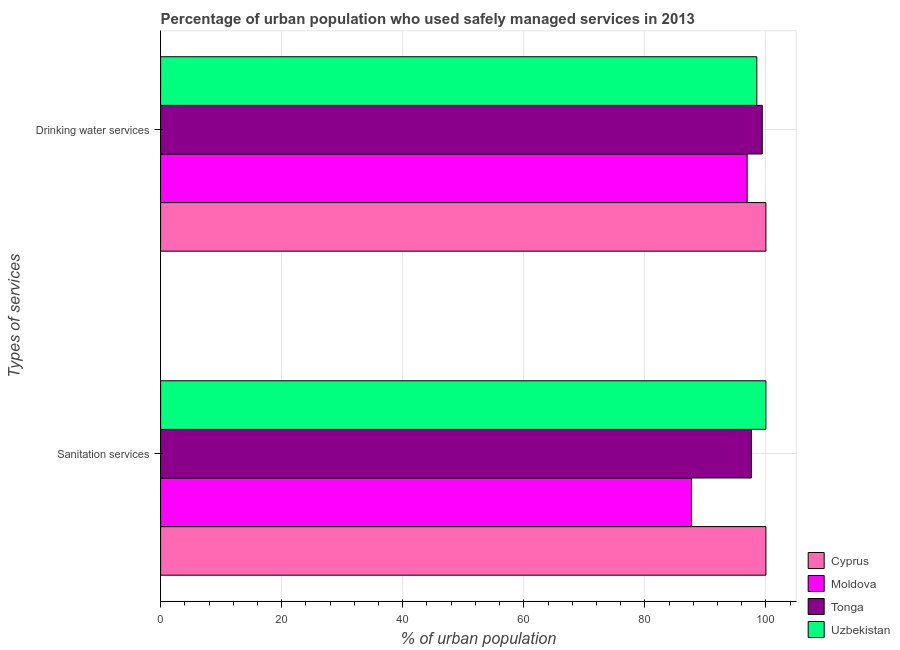How many different coloured bars are there?
Give a very brief answer. 4. How many groups of bars are there?
Keep it short and to the point. 2. How many bars are there on the 2nd tick from the top?
Provide a succinct answer. 4. How many bars are there on the 2nd tick from the bottom?
Keep it short and to the point. 4. What is the label of the 2nd group of bars from the top?
Your answer should be very brief. Sanitation services. What is the percentage of urban population who used drinking water services in Tonga?
Offer a very short reply. 99.4. Across all countries, what is the minimum percentage of urban population who used drinking water services?
Keep it short and to the point. 96.9. In which country was the percentage of urban population who used drinking water services maximum?
Make the answer very short. Cyprus. In which country was the percentage of urban population who used sanitation services minimum?
Ensure brevity in your answer.  Moldova. What is the total percentage of urban population who used sanitation services in the graph?
Your answer should be compact. 385.3. What is the difference between the percentage of urban population who used sanitation services in Cyprus and that in Uzbekistan?
Ensure brevity in your answer.  0. What is the difference between the percentage of urban population who used sanitation services in Tonga and the percentage of urban population who used drinking water services in Moldova?
Offer a very short reply. 0.7. What is the average percentage of urban population who used drinking water services per country?
Provide a succinct answer. 98.7. What is the difference between the percentage of urban population who used drinking water services and percentage of urban population who used sanitation services in Tonga?
Keep it short and to the point. 1.8. In how many countries, is the percentage of urban population who used sanitation services greater than 84 %?
Give a very brief answer. 4. What is the ratio of the percentage of urban population who used drinking water services in Uzbekistan to that in Tonga?
Offer a very short reply. 0.99. What does the 1st bar from the top in Sanitation services represents?
Keep it short and to the point. Uzbekistan. What does the 3rd bar from the bottom in Drinking water services represents?
Keep it short and to the point. Tonga. How many bars are there?
Provide a short and direct response. 8. What is the difference between two consecutive major ticks on the X-axis?
Provide a short and direct response. 20. Are the values on the major ticks of X-axis written in scientific E-notation?
Offer a terse response. No. Does the graph contain any zero values?
Give a very brief answer. No. How many legend labels are there?
Offer a terse response. 4. What is the title of the graph?
Your answer should be compact. Percentage of urban population who used safely managed services in 2013. What is the label or title of the X-axis?
Make the answer very short. % of urban population. What is the label or title of the Y-axis?
Your response must be concise. Types of services. What is the % of urban population in Moldova in Sanitation services?
Provide a short and direct response. 87.7. What is the % of urban population of Tonga in Sanitation services?
Keep it short and to the point. 97.6. What is the % of urban population of Uzbekistan in Sanitation services?
Keep it short and to the point. 100. What is the % of urban population of Cyprus in Drinking water services?
Your answer should be very brief. 100. What is the % of urban population of Moldova in Drinking water services?
Make the answer very short. 96.9. What is the % of urban population in Tonga in Drinking water services?
Keep it short and to the point. 99.4. What is the % of urban population in Uzbekistan in Drinking water services?
Your answer should be very brief. 98.5. Across all Types of services, what is the maximum % of urban population in Moldova?
Keep it short and to the point. 96.9. Across all Types of services, what is the maximum % of urban population of Tonga?
Offer a terse response. 99.4. Across all Types of services, what is the minimum % of urban population of Cyprus?
Provide a short and direct response. 100. Across all Types of services, what is the minimum % of urban population of Moldova?
Ensure brevity in your answer.  87.7. Across all Types of services, what is the minimum % of urban population of Tonga?
Give a very brief answer. 97.6. Across all Types of services, what is the minimum % of urban population in Uzbekistan?
Provide a succinct answer. 98.5. What is the total % of urban population in Cyprus in the graph?
Your response must be concise. 200. What is the total % of urban population in Moldova in the graph?
Offer a very short reply. 184.6. What is the total % of urban population of Tonga in the graph?
Provide a succinct answer. 197. What is the total % of urban population of Uzbekistan in the graph?
Provide a short and direct response. 198.5. What is the difference between the % of urban population of Cyprus in Sanitation services and that in Drinking water services?
Give a very brief answer. 0. What is the difference between the % of urban population in Tonga in Sanitation services and that in Drinking water services?
Ensure brevity in your answer.  -1.8. What is the difference between the % of urban population of Uzbekistan in Sanitation services and that in Drinking water services?
Offer a very short reply. 1.5. What is the difference between the % of urban population in Cyprus in Sanitation services and the % of urban population in Tonga in Drinking water services?
Your answer should be compact. 0.6. What is the difference between the % of urban population of Moldova in Sanitation services and the % of urban population of Tonga in Drinking water services?
Give a very brief answer. -11.7. What is the average % of urban population in Cyprus per Types of services?
Make the answer very short. 100. What is the average % of urban population in Moldova per Types of services?
Your answer should be very brief. 92.3. What is the average % of urban population of Tonga per Types of services?
Your response must be concise. 98.5. What is the average % of urban population in Uzbekistan per Types of services?
Your response must be concise. 99.25. What is the difference between the % of urban population in Cyprus and % of urban population in Moldova in Sanitation services?
Make the answer very short. 12.3. What is the difference between the % of urban population of Cyprus and % of urban population of Tonga in Sanitation services?
Offer a terse response. 2.4. What is the difference between the % of urban population of Cyprus and % of urban population of Uzbekistan in Sanitation services?
Ensure brevity in your answer.  0. What is the difference between the % of urban population of Moldova and % of urban population of Tonga in Sanitation services?
Keep it short and to the point. -9.9. What is the difference between the % of urban population in Tonga and % of urban population in Uzbekistan in Sanitation services?
Provide a short and direct response. -2.4. What is the difference between the % of urban population of Cyprus and % of urban population of Moldova in Drinking water services?
Offer a very short reply. 3.1. What is the difference between the % of urban population of Cyprus and % of urban population of Uzbekistan in Drinking water services?
Your answer should be compact. 1.5. What is the difference between the % of urban population of Moldova and % of urban population of Uzbekistan in Drinking water services?
Provide a short and direct response. -1.6. What is the difference between the % of urban population in Tonga and % of urban population in Uzbekistan in Drinking water services?
Your answer should be compact. 0.9. What is the ratio of the % of urban population in Cyprus in Sanitation services to that in Drinking water services?
Keep it short and to the point. 1. What is the ratio of the % of urban population in Moldova in Sanitation services to that in Drinking water services?
Make the answer very short. 0.91. What is the ratio of the % of urban population of Tonga in Sanitation services to that in Drinking water services?
Provide a short and direct response. 0.98. What is the ratio of the % of urban population in Uzbekistan in Sanitation services to that in Drinking water services?
Ensure brevity in your answer.  1.02. What is the difference between the highest and the second highest % of urban population in Moldova?
Provide a succinct answer. 9.2. What is the difference between the highest and the second highest % of urban population in Tonga?
Offer a very short reply. 1.8. What is the difference between the highest and the lowest % of urban population in Cyprus?
Make the answer very short. 0. What is the difference between the highest and the lowest % of urban population of Moldova?
Offer a terse response. 9.2. What is the difference between the highest and the lowest % of urban population of Tonga?
Offer a terse response. 1.8. What is the difference between the highest and the lowest % of urban population of Uzbekistan?
Provide a succinct answer. 1.5. 